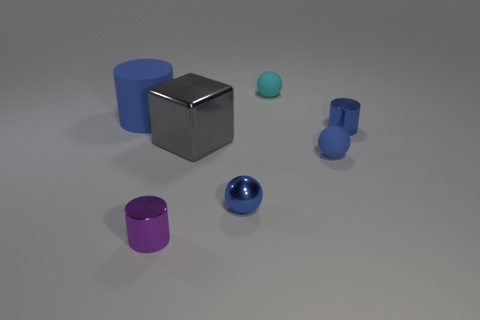Add 3 small shiny spheres. How many objects exist? 10 Subtract all cyan spheres. How many spheres are left? 2 Subtract all purple cylinders. How many cylinders are left? 2 Subtract all spheres. How many objects are left? 4 Subtract all blue rubber objects. Subtract all blue metallic things. How many objects are left? 3 Add 5 small rubber things. How many small rubber things are left? 7 Add 1 cyan objects. How many cyan objects exist? 2 Subtract 0 yellow cylinders. How many objects are left? 7 Subtract all brown balls. Subtract all green cylinders. How many balls are left? 3 Subtract all yellow balls. How many red cubes are left? 0 